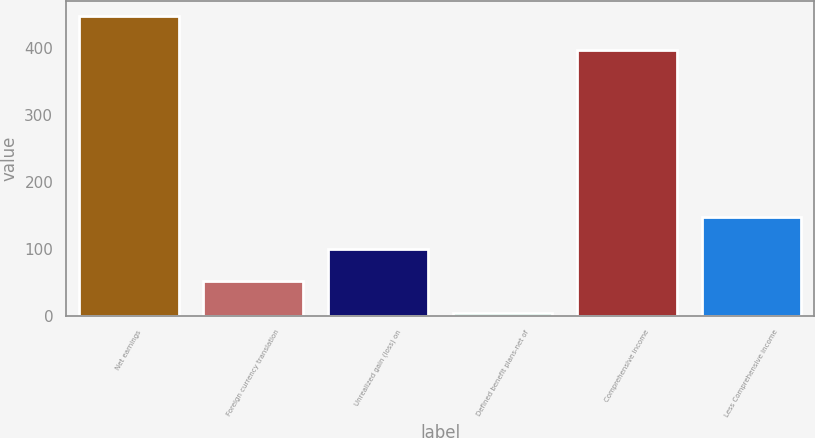Convert chart to OTSL. <chart><loc_0><loc_0><loc_500><loc_500><bar_chart><fcel>Net earnings<fcel>Foreign currency translation<fcel>Unrealized gain (loss) on<fcel>Defined benefit plans-net of<fcel>Comprehensive income<fcel>Less Comprehensive income<nl><fcel>448.5<fcel>52.25<fcel>100.2<fcel>4.3<fcel>397.6<fcel>148.15<nl></chart> 